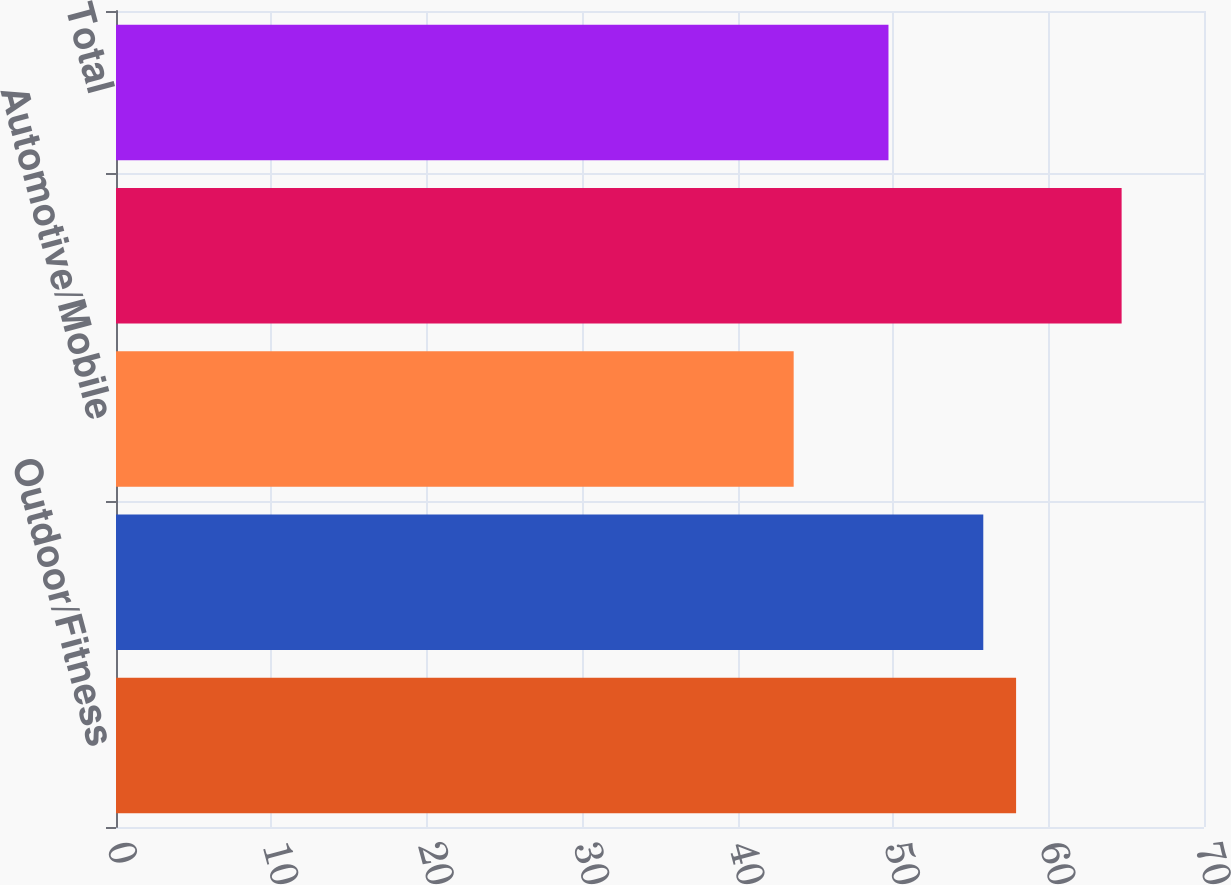<chart> <loc_0><loc_0><loc_500><loc_500><bar_chart><fcel>Outdoor/Fitness<fcel>Marine<fcel>Automotive/Mobile<fcel>Aviation<fcel>Total<nl><fcel>57.91<fcel>55.8<fcel>43.6<fcel>64.7<fcel>49.7<nl></chart> 